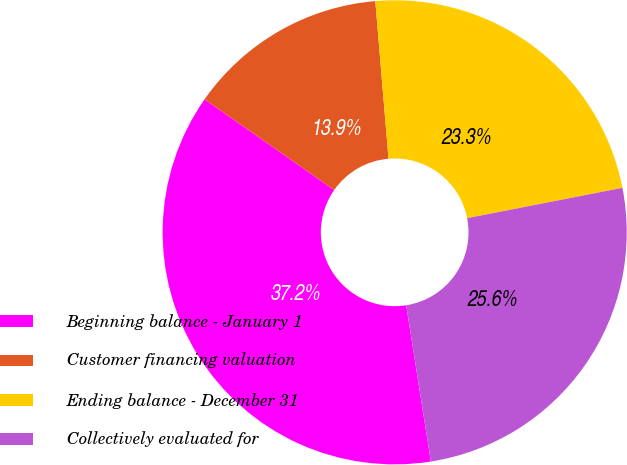Convert chart to OTSL. <chart><loc_0><loc_0><loc_500><loc_500><pie_chart><fcel>Beginning balance - January 1<fcel>Customer financing valuation<fcel>Ending balance - December 31<fcel>Collectively evaluated for<nl><fcel>37.21%<fcel>13.95%<fcel>23.26%<fcel>25.58%<nl></chart> 